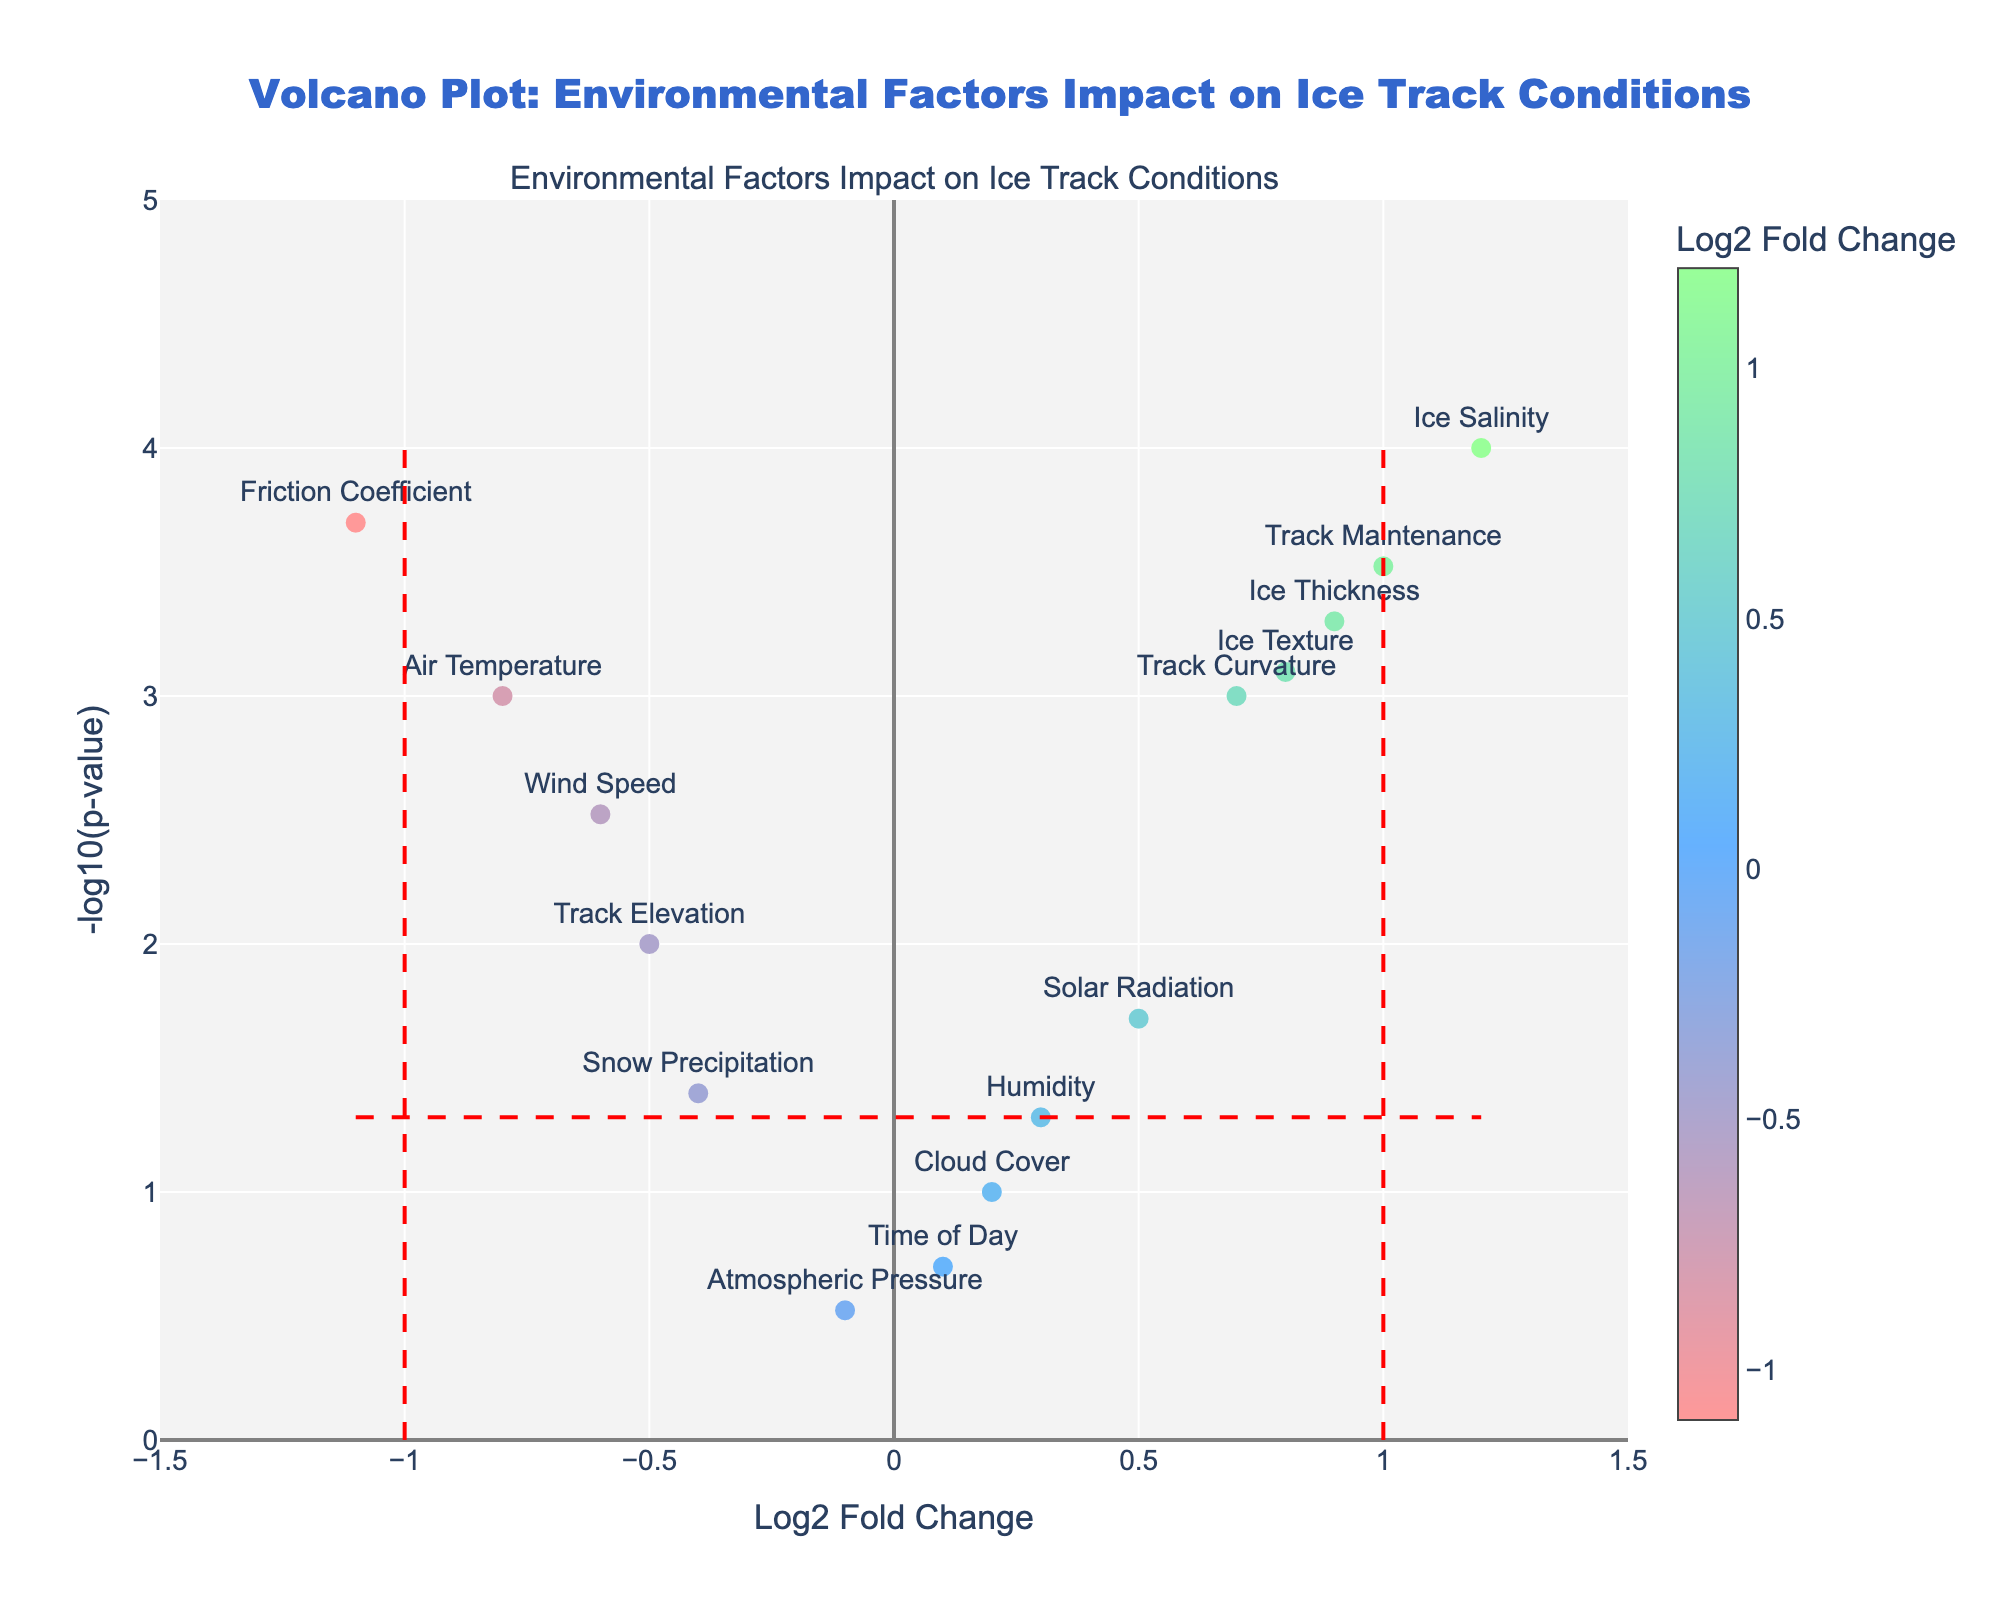What is the title of the plot? The title of the plot is typically displayed prominently at the top of the figure. In this case, the title is stated within the code provided.
Answer: Volcano Plot: Environmental Factors Impact on Ice Track Conditions How many data points have a Log2 Fold Change less than -1? To find the number of data points with a Log2 Fold Change less than -1, locate the vertical dashed line at x = -1. Count the number of points to the left of this line.
Answer: 1 Which environmental factor has the highest -log10(p-value)? Look at the y-axis values and identify the point that is plotted the highest on the y-axis. Then, refer to the text labels to determine which environmental factor it corresponds to.
Answer: Ice Salinity Which environmental factor has the smallest negative Log2 Fold Change? Find the smallest negative Log2 Fold Change on the x-axis, which is the point furthest to the left, but still above -1. Look at the text label for this point.
Answer: Friction Coefficient Which factors are above the significance threshold (p-value < 0.05) but have a Log2 Fold Change between -1 and 1? The significance threshold corresponds to the horizontal line at y = -log10(0.05). Points above this line and between the vertical lines at x = -1 and x = 1 meet this criterion. Count these points and check their labels.
Answer: Solar Radiation, Humidity, Snow Precipitation, and Track Elevation How does Ice Texture compare to Ice Thickness in terms of significance? Compare the y-axis positions of the points labeled as Ice Texture and Ice Thickness. Higher positions indicate greater significance (-log10(p-value)).
Answer: Ice Texture is less significant than Ice Thickness Which environmental factor has the largest positive Log2 Fold Change and is also significant (p-value < 0.05)? Look for the highest point on the right side of the plot (positive Log2 Fold Change) that is above the horizontal threshold line. Check the label.
Answer: Ice Salinity What is the difference in -log10(p-value) between Ice Salinity and Air Temperature? Find the y-axis values (-log10(p-value)) for both Ice Salinity and Air Temperature. Subtract the value for Air Temperature from the value for Ice Salinity.
Answer: 2.7 Among Air Temperature and Wind Speed, which one shows a stronger effect on ice track conditions based on Log2 Fold Change? Compare the x-axis values (Log2 Fold Change) of points labeled as Air Temperature and Wind Speed. The one with a larger absolute value has a stronger effect.
Answer: Air Temperature has a stronger effect 